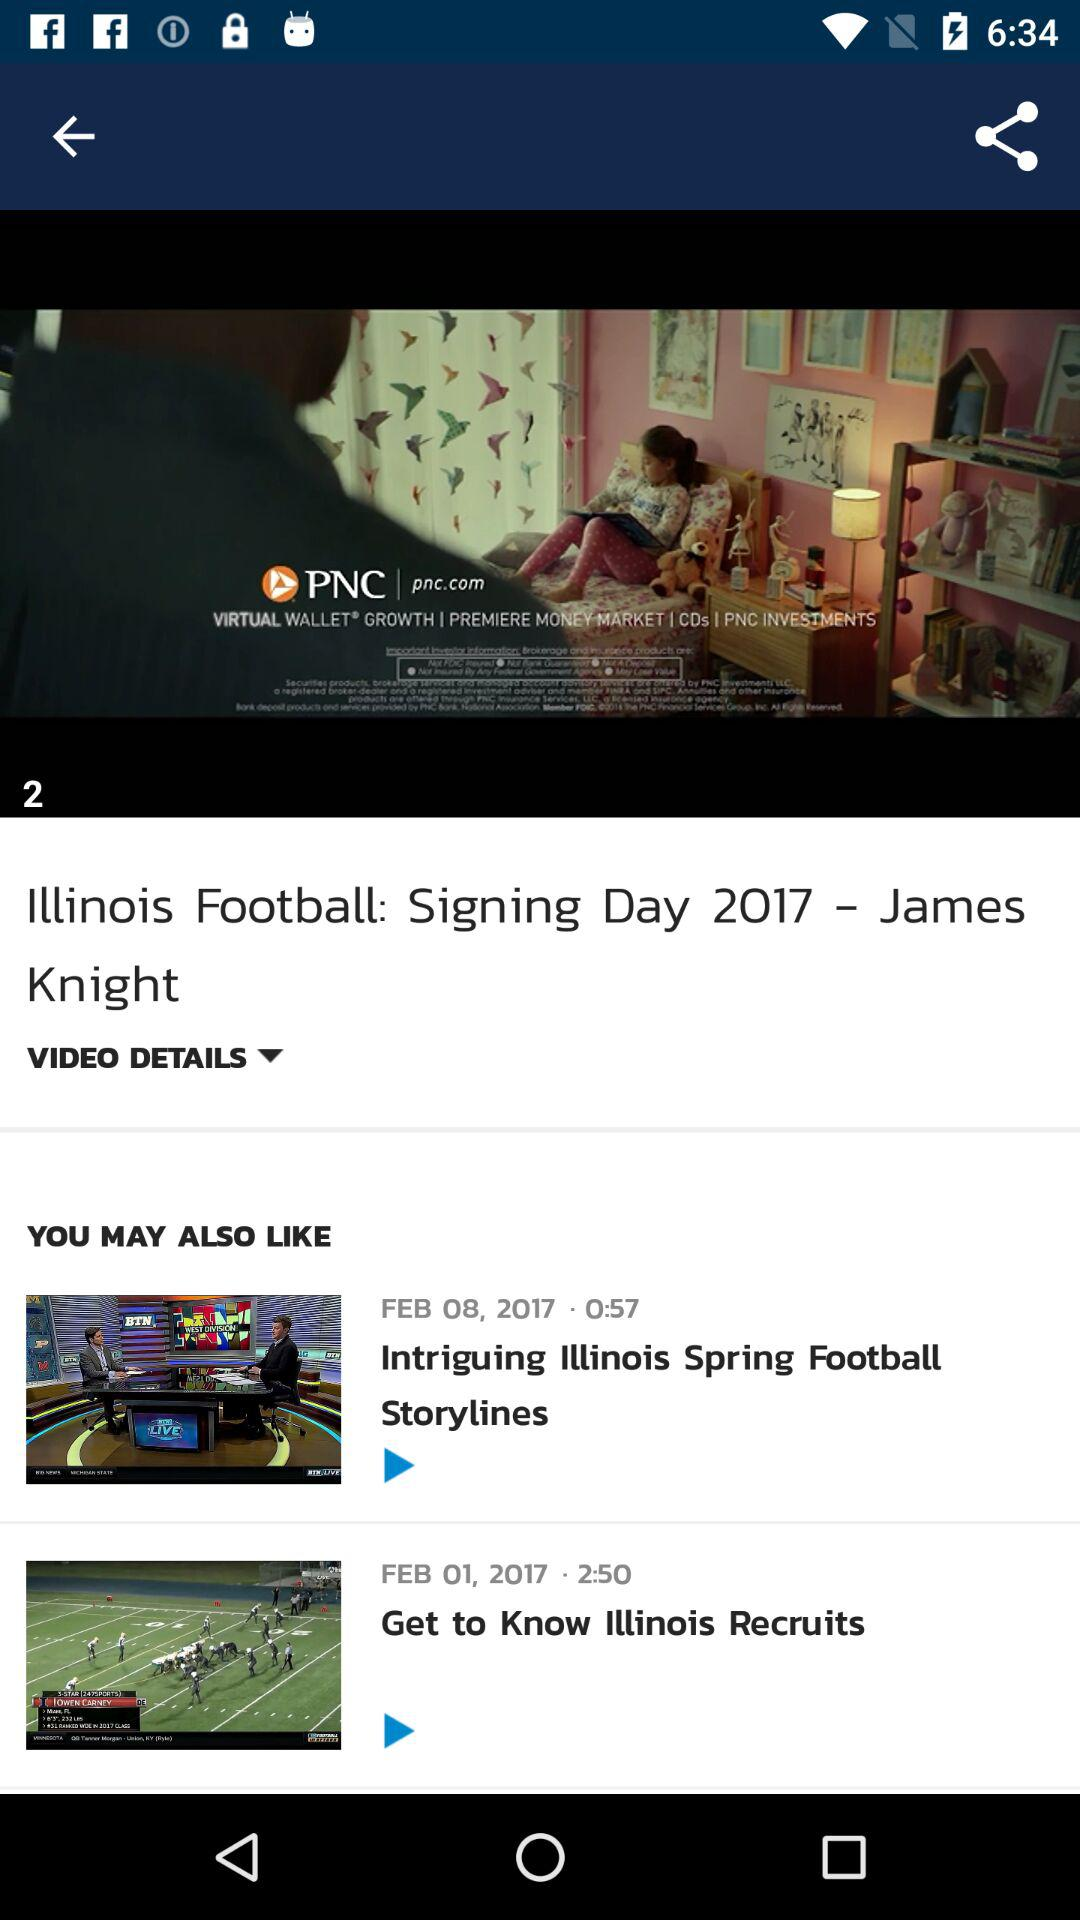On which date was the video "Get to Know Illinois Recruits" updated? The video "Get to Know Illinois Recruits" was updated on February 1, 2017. 